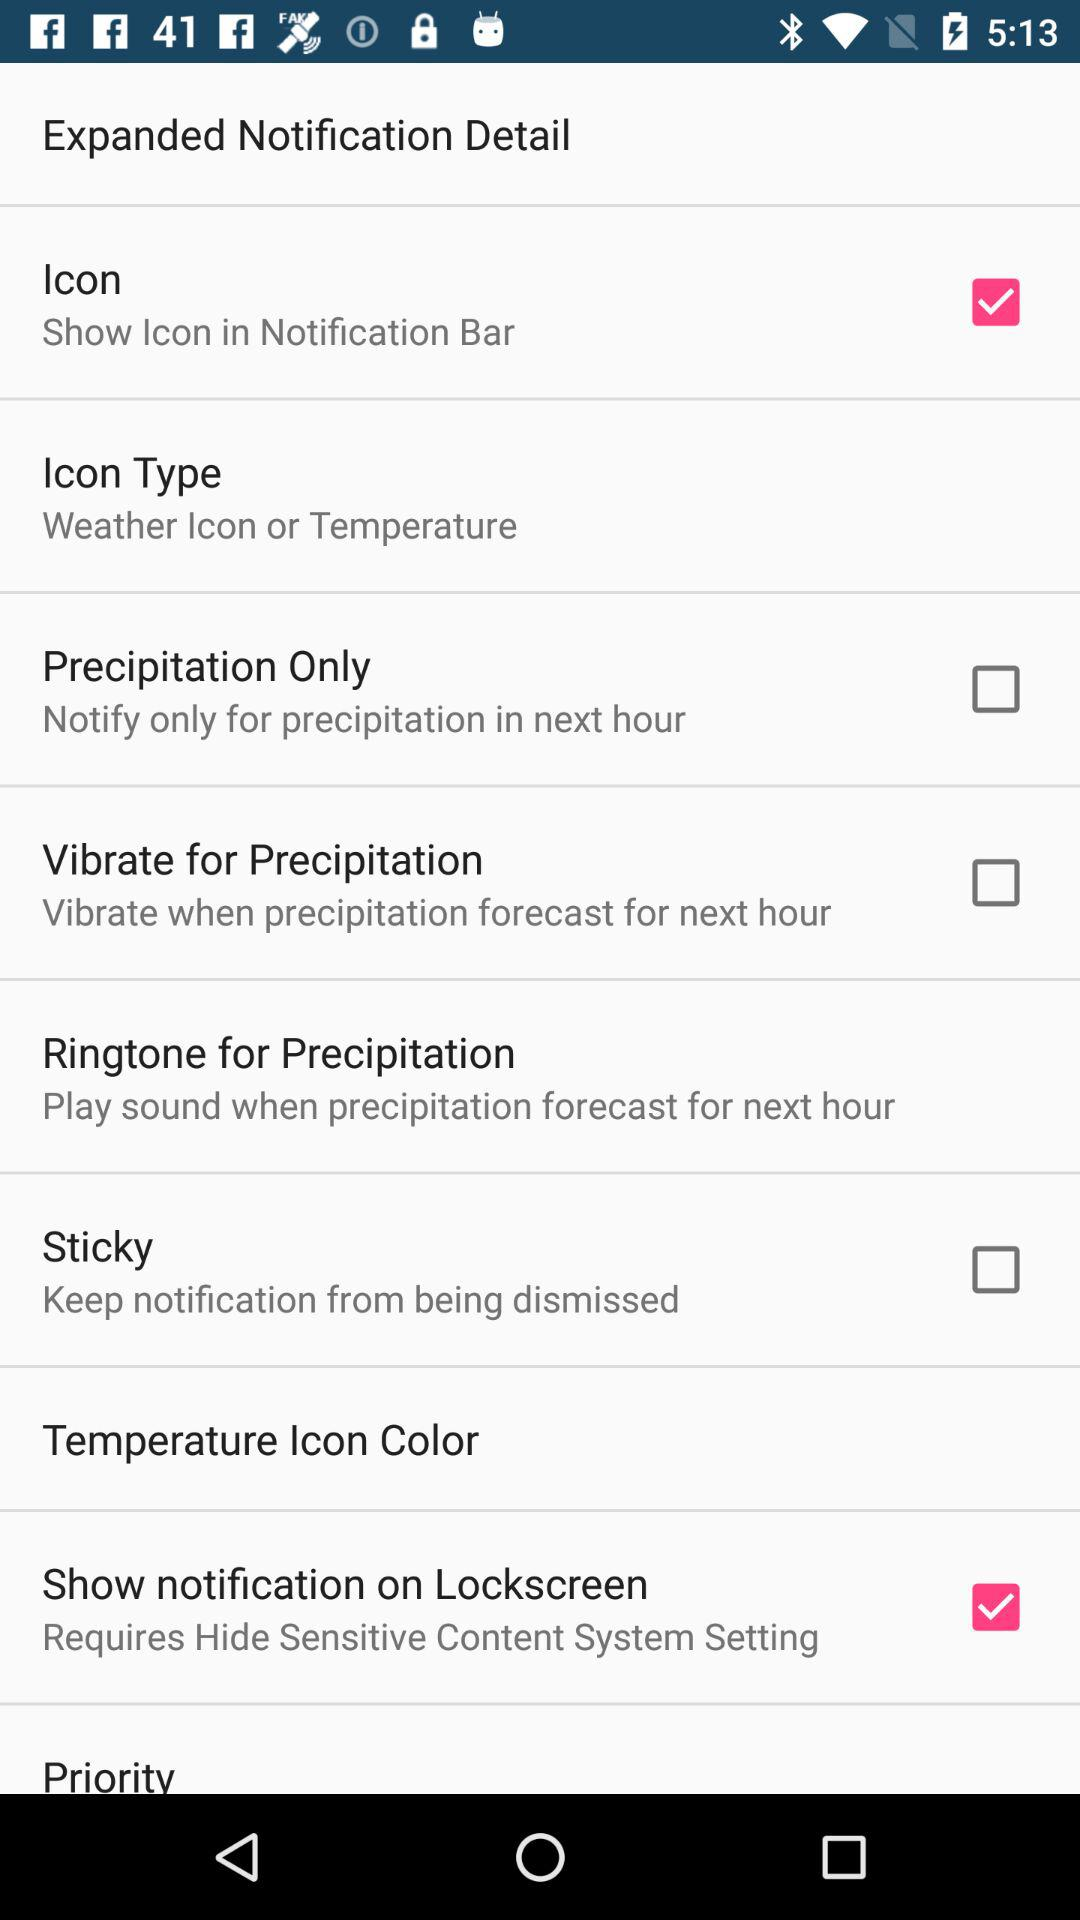What is the status of "Icon"? The status is "on". 